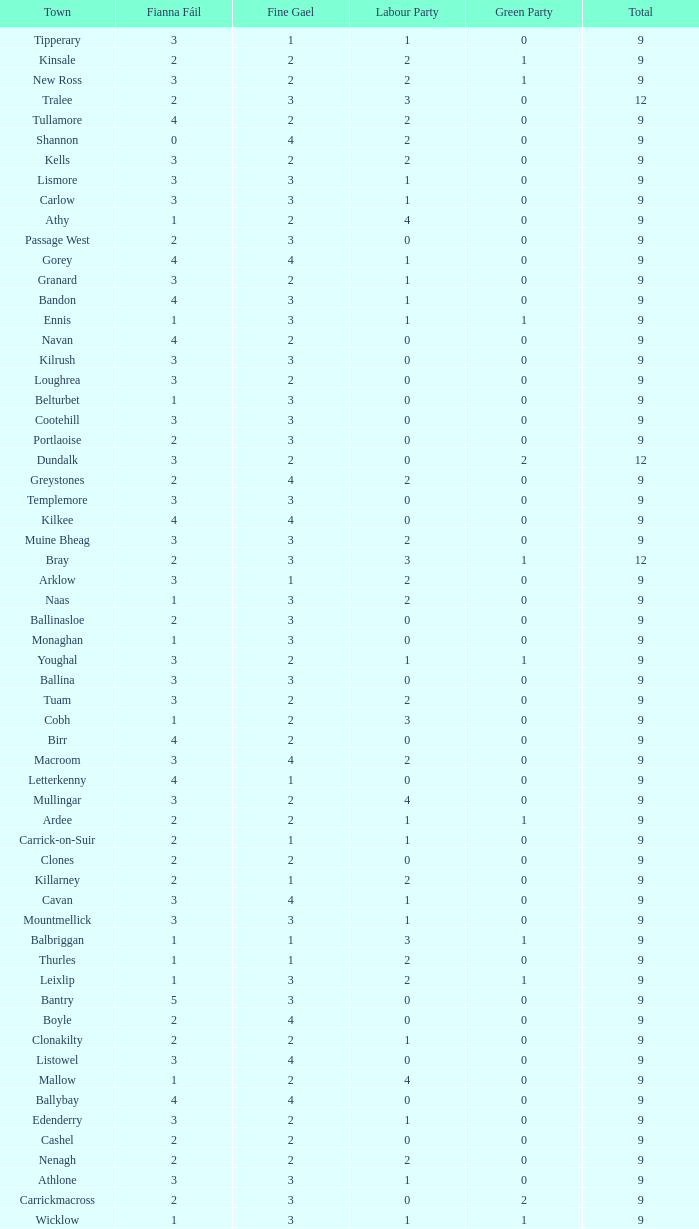How many are in the Labour Party of a Fianna Fail of 3 with a total higher than 9 and more than 2 in the Green Party? None. Can you parse all the data within this table? {'header': ['Town', 'Fianna Fáil', 'Fine Gael', 'Labour Party', 'Green Party', 'Total'], 'rows': [['Tipperary', '3', '1', '1', '0', '9'], ['Kinsale', '2', '2', '2', '1', '9'], ['New Ross', '3', '2', '2', '1', '9'], ['Tralee', '2', '3', '3', '0', '12'], ['Tullamore', '4', '2', '2', '0', '9'], ['Shannon', '0', '4', '2', '0', '9'], ['Kells', '3', '2', '2', '0', '9'], ['Lismore', '3', '3', '1', '0', '9'], ['Carlow', '3', '3', '1', '0', '9'], ['Athy', '1', '2', '4', '0', '9'], ['Passage West', '2', '3', '0', '0', '9'], ['Gorey', '4', '4', '1', '0', '9'], ['Granard', '3', '2', '1', '0', '9'], ['Bandon', '4', '3', '1', '0', '9'], ['Ennis', '1', '3', '1', '1', '9'], ['Navan', '4', '2', '0', '0', '9'], ['Kilrush', '3', '3', '0', '0', '9'], ['Loughrea', '3', '2', '0', '0', '9'], ['Belturbet', '1', '3', '0', '0', '9'], ['Cootehill', '3', '3', '0', '0', '9'], ['Portlaoise', '2', '3', '0', '0', '9'], ['Dundalk', '3', '2', '0', '2', '12'], ['Greystones', '2', '4', '2', '0', '9'], ['Templemore', '3', '3', '0', '0', '9'], ['Kilkee', '4', '4', '0', '0', '9'], ['Muine Bheag', '3', '3', '2', '0', '9'], ['Bray', '2', '3', '3', '1', '12'], ['Arklow', '3', '1', '2', '0', '9'], ['Naas', '1', '3', '2', '0', '9'], ['Ballinasloe', '2', '3', '0', '0', '9'], ['Monaghan', '1', '3', '0', '0', '9'], ['Youghal', '3', '2', '1', '1', '9'], ['Ballina', '3', '3', '0', '0', '9'], ['Tuam', '3', '2', '2', '0', '9'], ['Cobh', '1', '2', '3', '0', '9'], ['Birr', '4', '2', '0', '0', '9'], ['Macroom', '3', '4', '2', '0', '9'], ['Letterkenny', '4', '1', '0', '0', '9'], ['Mullingar', '3', '2', '4', '0', '9'], ['Ardee', '2', '2', '1', '1', '9'], ['Carrick-on-Suir', '2', '1', '1', '0', '9'], ['Clones', '2', '2', '0', '0', '9'], ['Killarney', '2', '1', '2', '0', '9'], ['Cavan', '3', '4', '1', '0', '9'], ['Mountmellick', '3', '3', '1', '0', '9'], ['Balbriggan', '1', '1', '3', '1', '9'], ['Thurles', '1', '1', '2', '0', '9'], ['Leixlip', '1', '3', '2', '1', '9'], ['Bantry', '5', '3', '0', '0', '9'], ['Boyle', '2', '4', '0', '0', '9'], ['Clonakilty', '2', '2', '1', '0', '9'], ['Listowel', '3', '4', '0', '0', '9'], ['Mallow', '1', '2', '4', '0', '9'], ['Ballybay', '4', '4', '0', '0', '9'], ['Edenderry', '3', '2', '1', '0', '9'], ['Cashel', '2', '2', '0', '0', '9'], ['Nenagh', '2', '2', '2', '0', '9'], ['Athlone', '3', '3', '1', '0', '9'], ['Carrickmacross', '2', '3', '0', '2', '9'], ['Wicklow', '1', '3', '1', '1', '9'], ['Dungarvan', '2', '3', '3', '0', '9'], ['Trim', '2', '3', '2', '0', '9'], ['Buncrana', '2', '3', '0', '0', '9'], ['Ballyshannon', '2', '5', '0', '0', '9'], ['Westport', '2', '5', '1', '0', '9'], ['Castlebar', '1', '4', '1', '0', '9'], ['Newbridge', '2', '2', '2', '0', '9'], ['Enniscorthy', '2', '2', '1', '0', '9'], ['Fermoy', '2', '2', '2', '0', '9'], ['Castleblayney', '3', '2', '0', '0', '9'], ['Midleton', '1', '2', '1', '0', '9'], ['Skibbereen', '2', '4', '2', '0', '9'], ['Tramore', '1', '4', '1', '0', '9'], ['Longford', '2', '3', '0', '0', '9'], ['Bundoran', '3', '2', '0', '0', '9']]} 